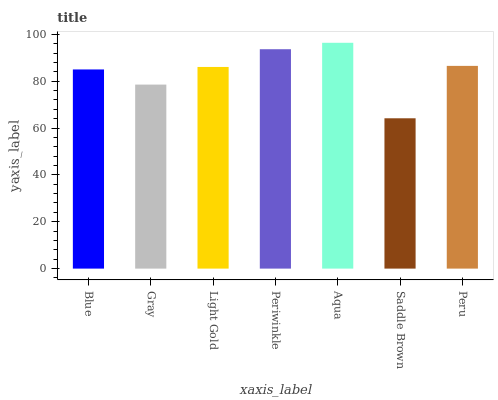Is Gray the minimum?
Answer yes or no. No. Is Gray the maximum?
Answer yes or no. No. Is Blue greater than Gray?
Answer yes or no. Yes. Is Gray less than Blue?
Answer yes or no. Yes. Is Gray greater than Blue?
Answer yes or no. No. Is Blue less than Gray?
Answer yes or no. No. Is Light Gold the high median?
Answer yes or no. Yes. Is Light Gold the low median?
Answer yes or no. Yes. Is Saddle Brown the high median?
Answer yes or no. No. Is Gray the low median?
Answer yes or no. No. 